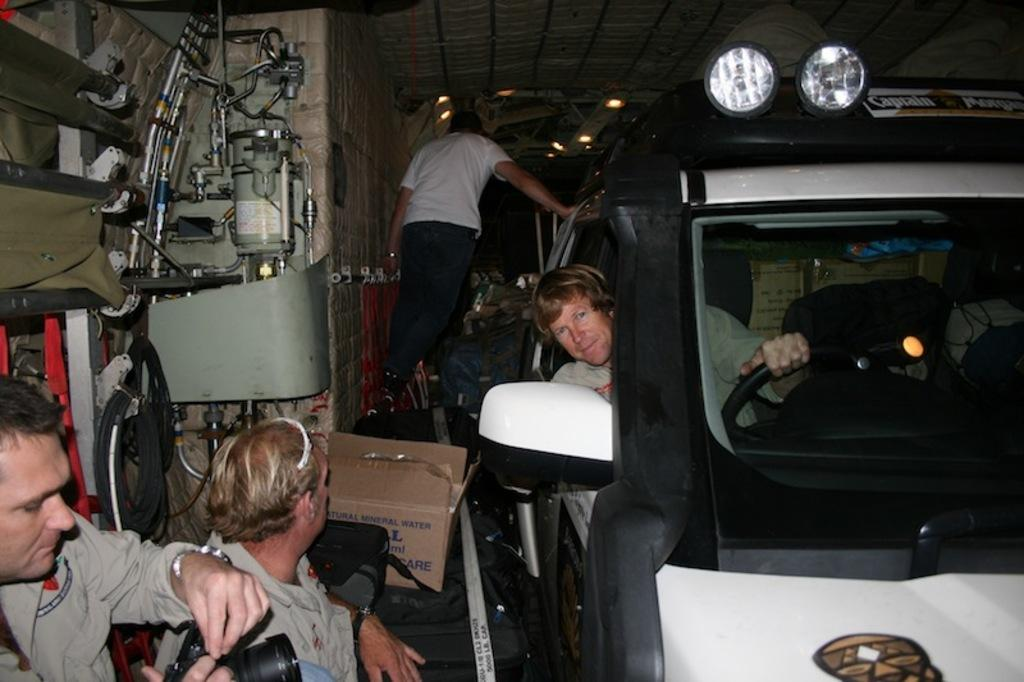How many people are in the image? There are four persons in the image. What is one of the persons doing in the image? One of the persons is sitting in a car. Can you describe the background of the image? There are many things visible in the image, and there are lights in the background. What type of quarter is being used to pay for the feast in the image? There is no quarter or feast present in the image. How many sons are visible in the image? There is no son or any indication of family relationships in the image. 